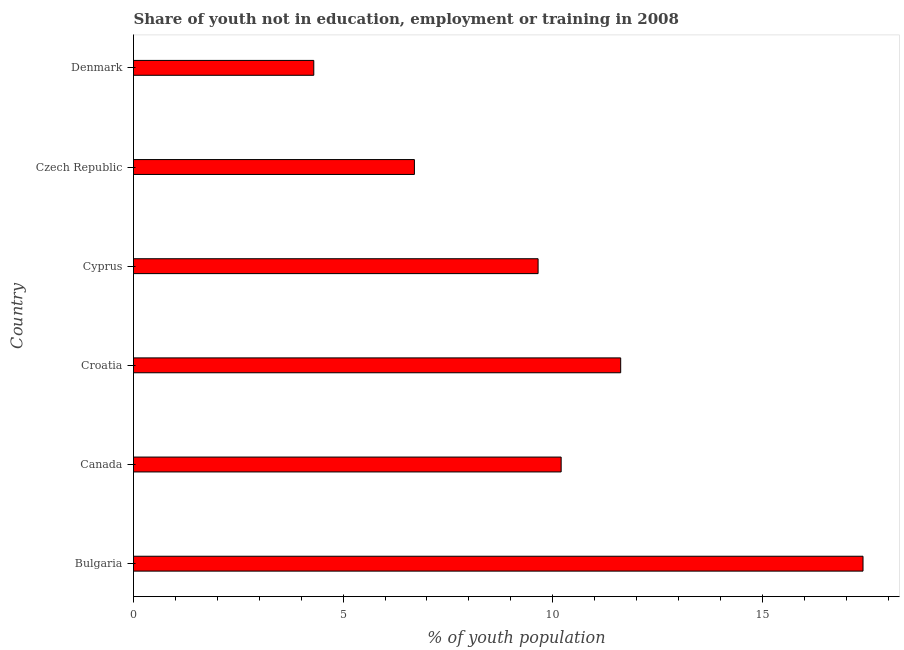What is the title of the graph?
Offer a terse response. Share of youth not in education, employment or training in 2008. What is the label or title of the X-axis?
Your answer should be compact. % of youth population. What is the label or title of the Y-axis?
Provide a succinct answer. Country. What is the unemployed youth population in Denmark?
Your response must be concise. 4.3. Across all countries, what is the maximum unemployed youth population?
Provide a succinct answer. 17.4. Across all countries, what is the minimum unemployed youth population?
Offer a very short reply. 4.3. What is the sum of the unemployed youth population?
Offer a terse response. 59.87. What is the difference between the unemployed youth population in Bulgaria and Cyprus?
Your answer should be very brief. 7.75. What is the average unemployed youth population per country?
Your answer should be compact. 9.98. What is the median unemployed youth population?
Keep it short and to the point. 9.92. What is the ratio of the unemployed youth population in Canada to that in Czech Republic?
Make the answer very short. 1.52. Is the difference between the unemployed youth population in Bulgaria and Denmark greater than the difference between any two countries?
Keep it short and to the point. Yes. What is the difference between the highest and the second highest unemployed youth population?
Offer a terse response. 5.78. What is the difference between the highest and the lowest unemployed youth population?
Keep it short and to the point. 13.1. What is the difference between two consecutive major ticks on the X-axis?
Keep it short and to the point. 5. Are the values on the major ticks of X-axis written in scientific E-notation?
Provide a succinct answer. No. What is the % of youth population of Bulgaria?
Provide a short and direct response. 17.4. What is the % of youth population of Canada?
Ensure brevity in your answer.  10.2. What is the % of youth population of Croatia?
Make the answer very short. 11.62. What is the % of youth population of Cyprus?
Your answer should be compact. 9.65. What is the % of youth population of Czech Republic?
Offer a very short reply. 6.7. What is the % of youth population of Denmark?
Your answer should be compact. 4.3. What is the difference between the % of youth population in Bulgaria and Canada?
Provide a succinct answer. 7.2. What is the difference between the % of youth population in Bulgaria and Croatia?
Provide a short and direct response. 5.78. What is the difference between the % of youth population in Bulgaria and Cyprus?
Offer a very short reply. 7.75. What is the difference between the % of youth population in Bulgaria and Czech Republic?
Keep it short and to the point. 10.7. What is the difference between the % of youth population in Canada and Croatia?
Make the answer very short. -1.42. What is the difference between the % of youth population in Canada and Cyprus?
Offer a terse response. 0.55. What is the difference between the % of youth population in Croatia and Cyprus?
Offer a very short reply. 1.97. What is the difference between the % of youth population in Croatia and Czech Republic?
Your answer should be compact. 4.92. What is the difference between the % of youth population in Croatia and Denmark?
Give a very brief answer. 7.32. What is the difference between the % of youth population in Cyprus and Czech Republic?
Your answer should be very brief. 2.95. What is the difference between the % of youth population in Cyprus and Denmark?
Your answer should be compact. 5.35. What is the difference between the % of youth population in Czech Republic and Denmark?
Keep it short and to the point. 2.4. What is the ratio of the % of youth population in Bulgaria to that in Canada?
Your answer should be very brief. 1.71. What is the ratio of the % of youth population in Bulgaria to that in Croatia?
Provide a succinct answer. 1.5. What is the ratio of the % of youth population in Bulgaria to that in Cyprus?
Offer a very short reply. 1.8. What is the ratio of the % of youth population in Bulgaria to that in Czech Republic?
Your answer should be very brief. 2.6. What is the ratio of the % of youth population in Bulgaria to that in Denmark?
Keep it short and to the point. 4.05. What is the ratio of the % of youth population in Canada to that in Croatia?
Your answer should be very brief. 0.88. What is the ratio of the % of youth population in Canada to that in Cyprus?
Ensure brevity in your answer.  1.06. What is the ratio of the % of youth population in Canada to that in Czech Republic?
Your answer should be compact. 1.52. What is the ratio of the % of youth population in Canada to that in Denmark?
Provide a succinct answer. 2.37. What is the ratio of the % of youth population in Croatia to that in Cyprus?
Your response must be concise. 1.2. What is the ratio of the % of youth population in Croatia to that in Czech Republic?
Provide a short and direct response. 1.73. What is the ratio of the % of youth population in Croatia to that in Denmark?
Provide a succinct answer. 2.7. What is the ratio of the % of youth population in Cyprus to that in Czech Republic?
Ensure brevity in your answer.  1.44. What is the ratio of the % of youth population in Cyprus to that in Denmark?
Offer a very short reply. 2.24. What is the ratio of the % of youth population in Czech Republic to that in Denmark?
Offer a very short reply. 1.56. 